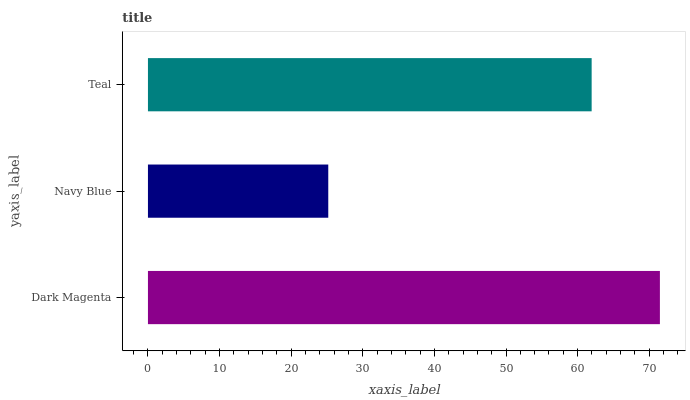Is Navy Blue the minimum?
Answer yes or no. Yes. Is Dark Magenta the maximum?
Answer yes or no. Yes. Is Teal the minimum?
Answer yes or no. No. Is Teal the maximum?
Answer yes or no. No. Is Teal greater than Navy Blue?
Answer yes or no. Yes. Is Navy Blue less than Teal?
Answer yes or no. Yes. Is Navy Blue greater than Teal?
Answer yes or no. No. Is Teal less than Navy Blue?
Answer yes or no. No. Is Teal the high median?
Answer yes or no. Yes. Is Teal the low median?
Answer yes or no. Yes. Is Navy Blue the high median?
Answer yes or no. No. Is Dark Magenta the low median?
Answer yes or no. No. 